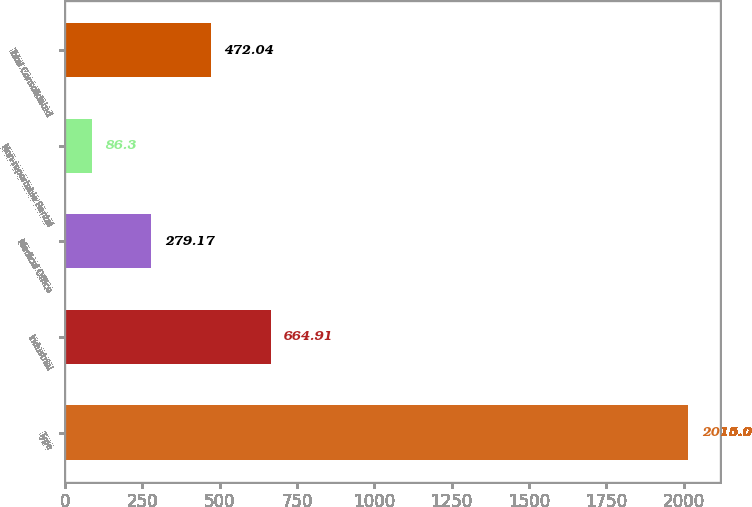Convert chart. <chart><loc_0><loc_0><loc_500><loc_500><bar_chart><fcel>Type<fcel>Industrial<fcel>Medical Office<fcel>Non-reportable Rental<fcel>Total Consolidated<nl><fcel>2015<fcel>664.91<fcel>279.17<fcel>86.3<fcel>472.04<nl></chart> 